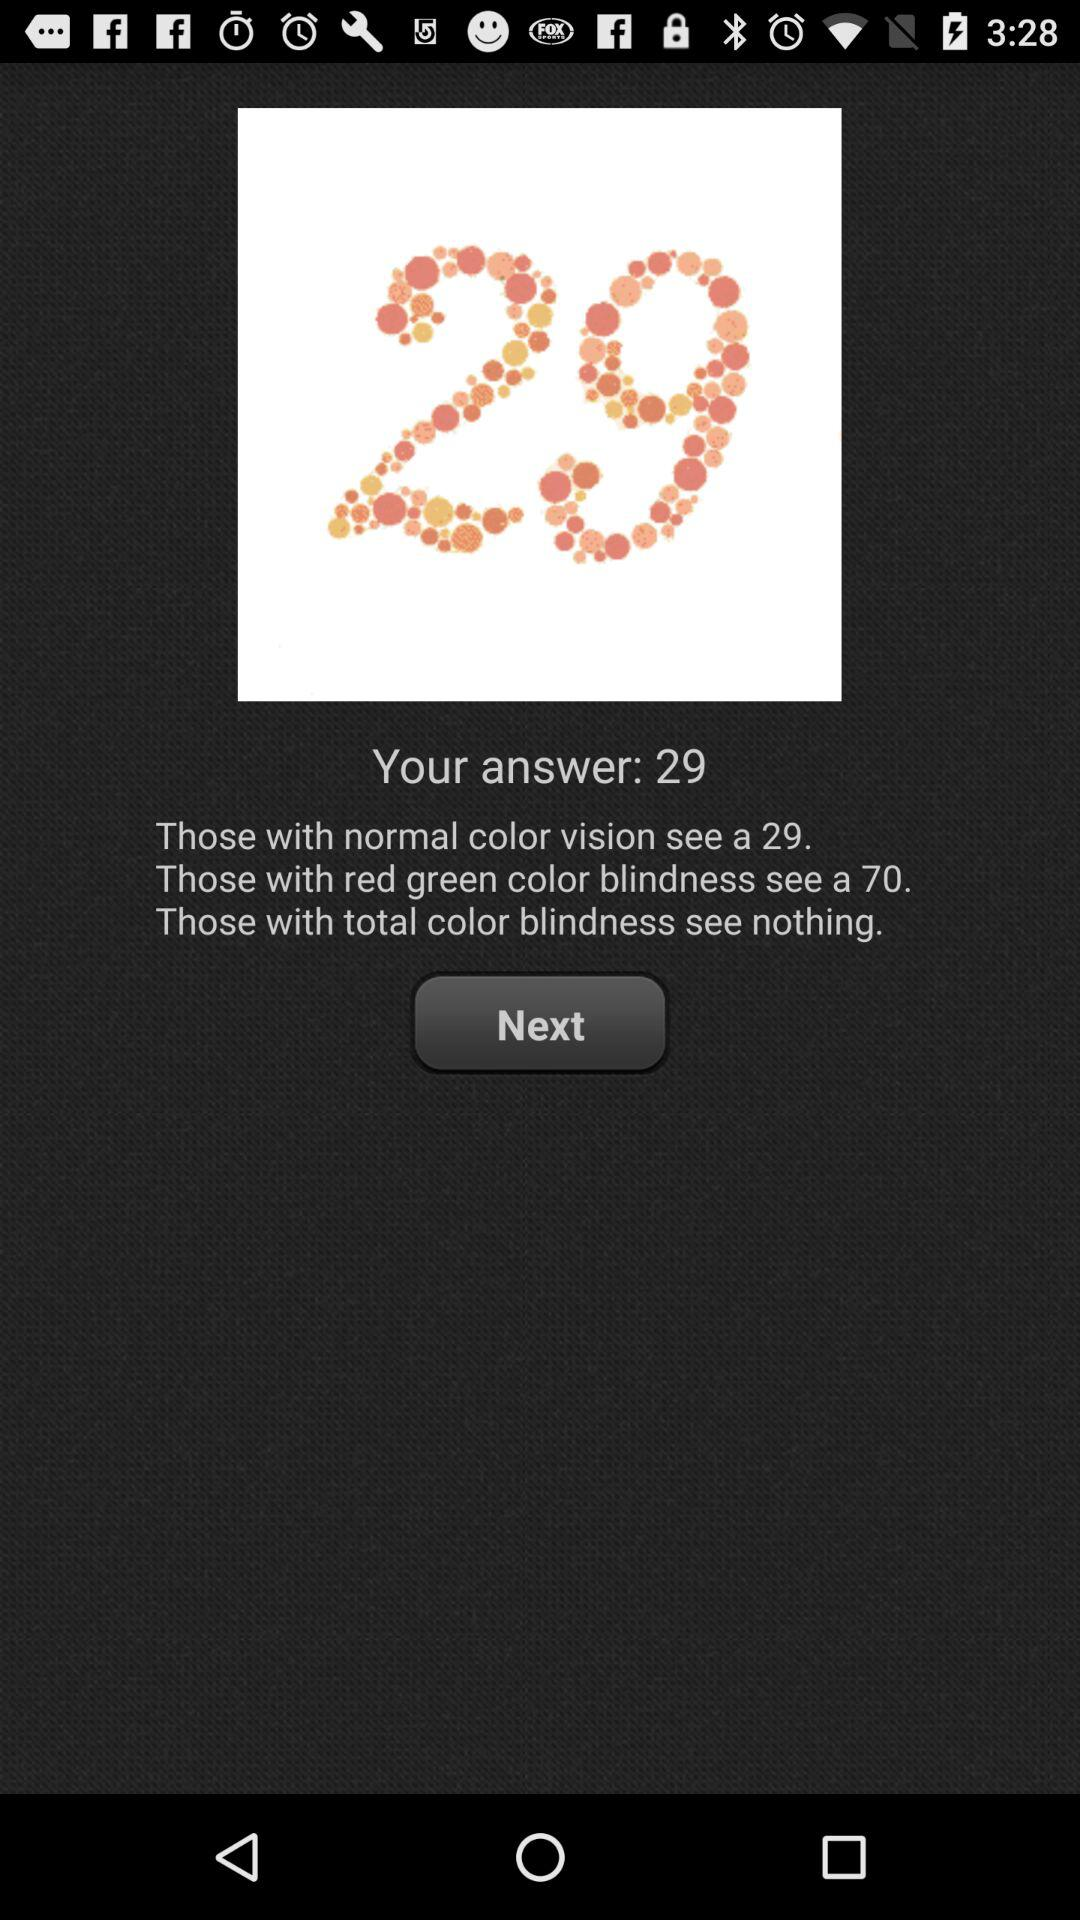If a person has total color blindness, how many circles would they see in the number 29?
Answer the question using a single word or phrase. 0 